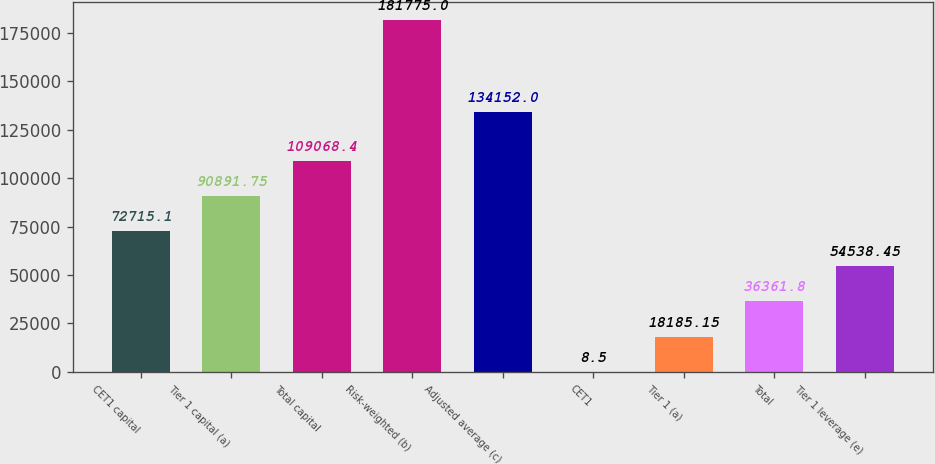Convert chart. <chart><loc_0><loc_0><loc_500><loc_500><bar_chart><fcel>CET1 capital<fcel>Tier 1 capital (a)<fcel>Total capital<fcel>Risk-weighted (b)<fcel>Adjusted average (c)<fcel>CET1<fcel>Tier 1 (a)<fcel>Total<fcel>Tier 1 leverage (e)<nl><fcel>72715.1<fcel>90891.8<fcel>109068<fcel>181775<fcel>134152<fcel>8.5<fcel>18185.2<fcel>36361.8<fcel>54538.4<nl></chart> 